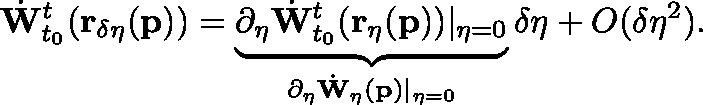<formula> <loc_0><loc_0><loc_500><loc_500>\dot { W } _ { t _ { 0 } } ^ { t } ( r _ { \delta \eta } ( p ) ) = \underbrace { \partial _ { \eta } \dot { W } _ { t _ { 0 } } ^ { t } ( r _ { \eta } ( p ) ) | _ { \eta = 0 } } _ { \partial _ { \eta } \dot { W } _ { \eta } ( p ) | _ { \eta = 0 } } \delta \eta + O ( \delta \eta ^ { 2 } ) .</formula> 